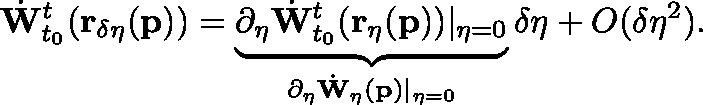<formula> <loc_0><loc_0><loc_500><loc_500>\dot { W } _ { t _ { 0 } } ^ { t } ( r _ { \delta \eta } ( p ) ) = \underbrace { \partial _ { \eta } \dot { W } _ { t _ { 0 } } ^ { t } ( r _ { \eta } ( p ) ) | _ { \eta = 0 } } _ { \partial _ { \eta } \dot { W } _ { \eta } ( p ) | _ { \eta = 0 } } \delta \eta + O ( \delta \eta ^ { 2 } ) .</formula> 